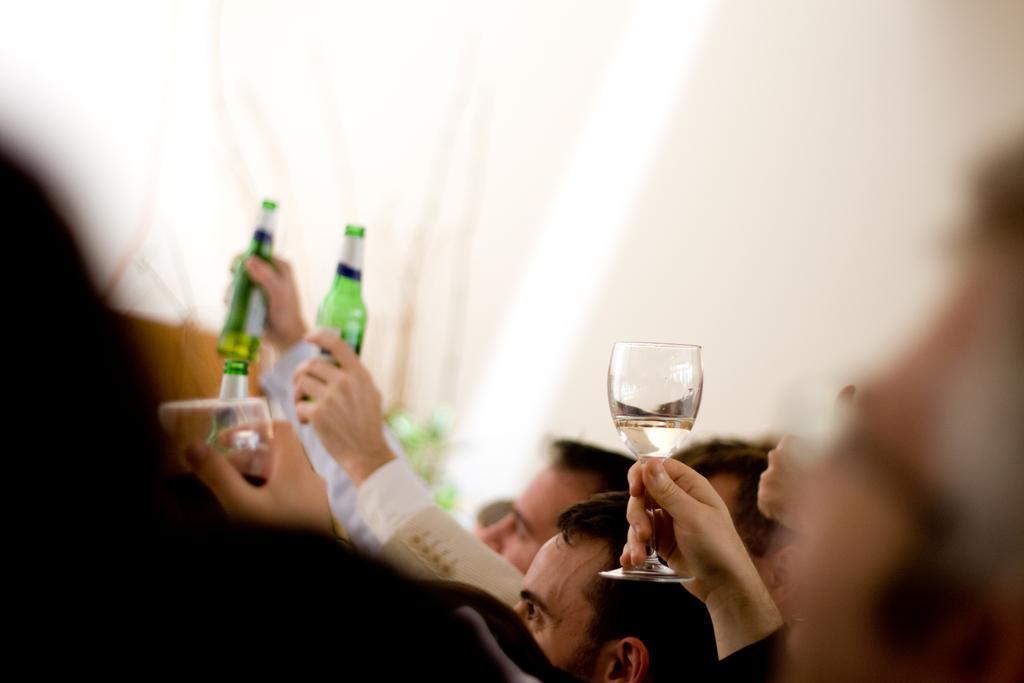In one or two sentences, can you explain what this image depicts? In this image, we can see group of peoples. Few are holding wine glasses. Few are holding bottles. 